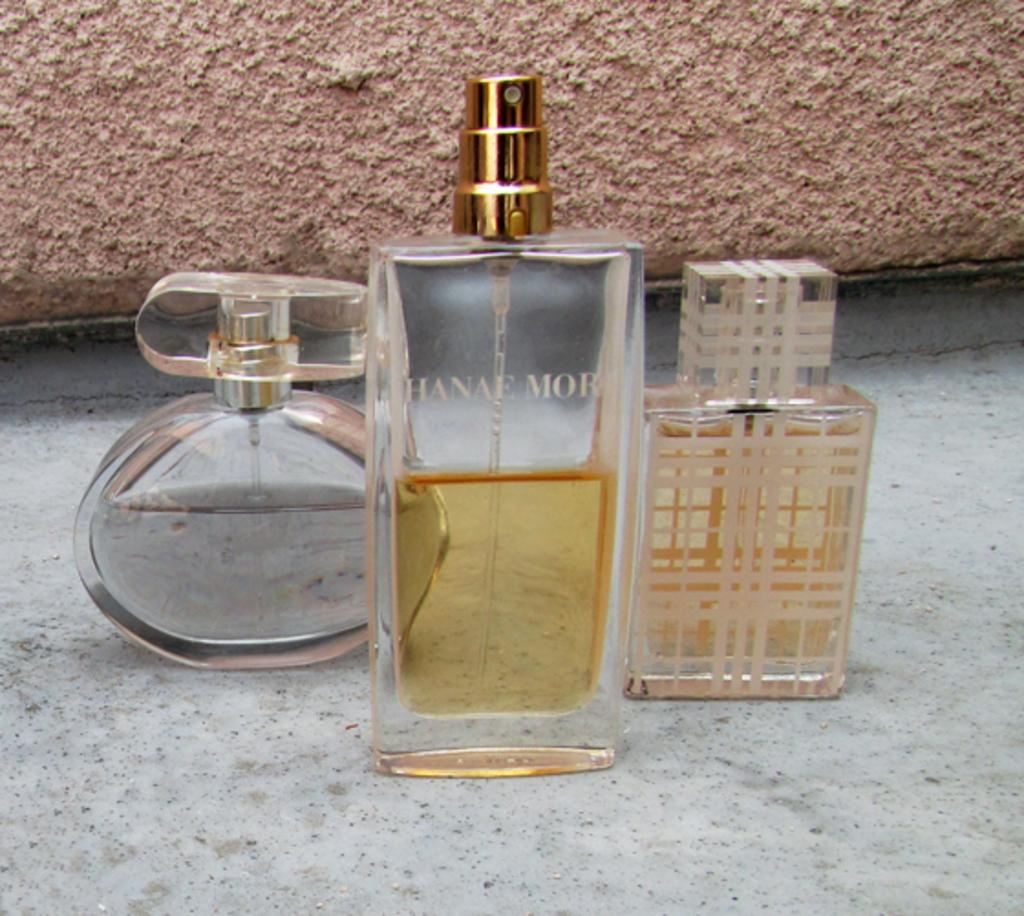<image>
Provide a brief description of the given image. a cologne item that has the name of Hanae Mori on it 